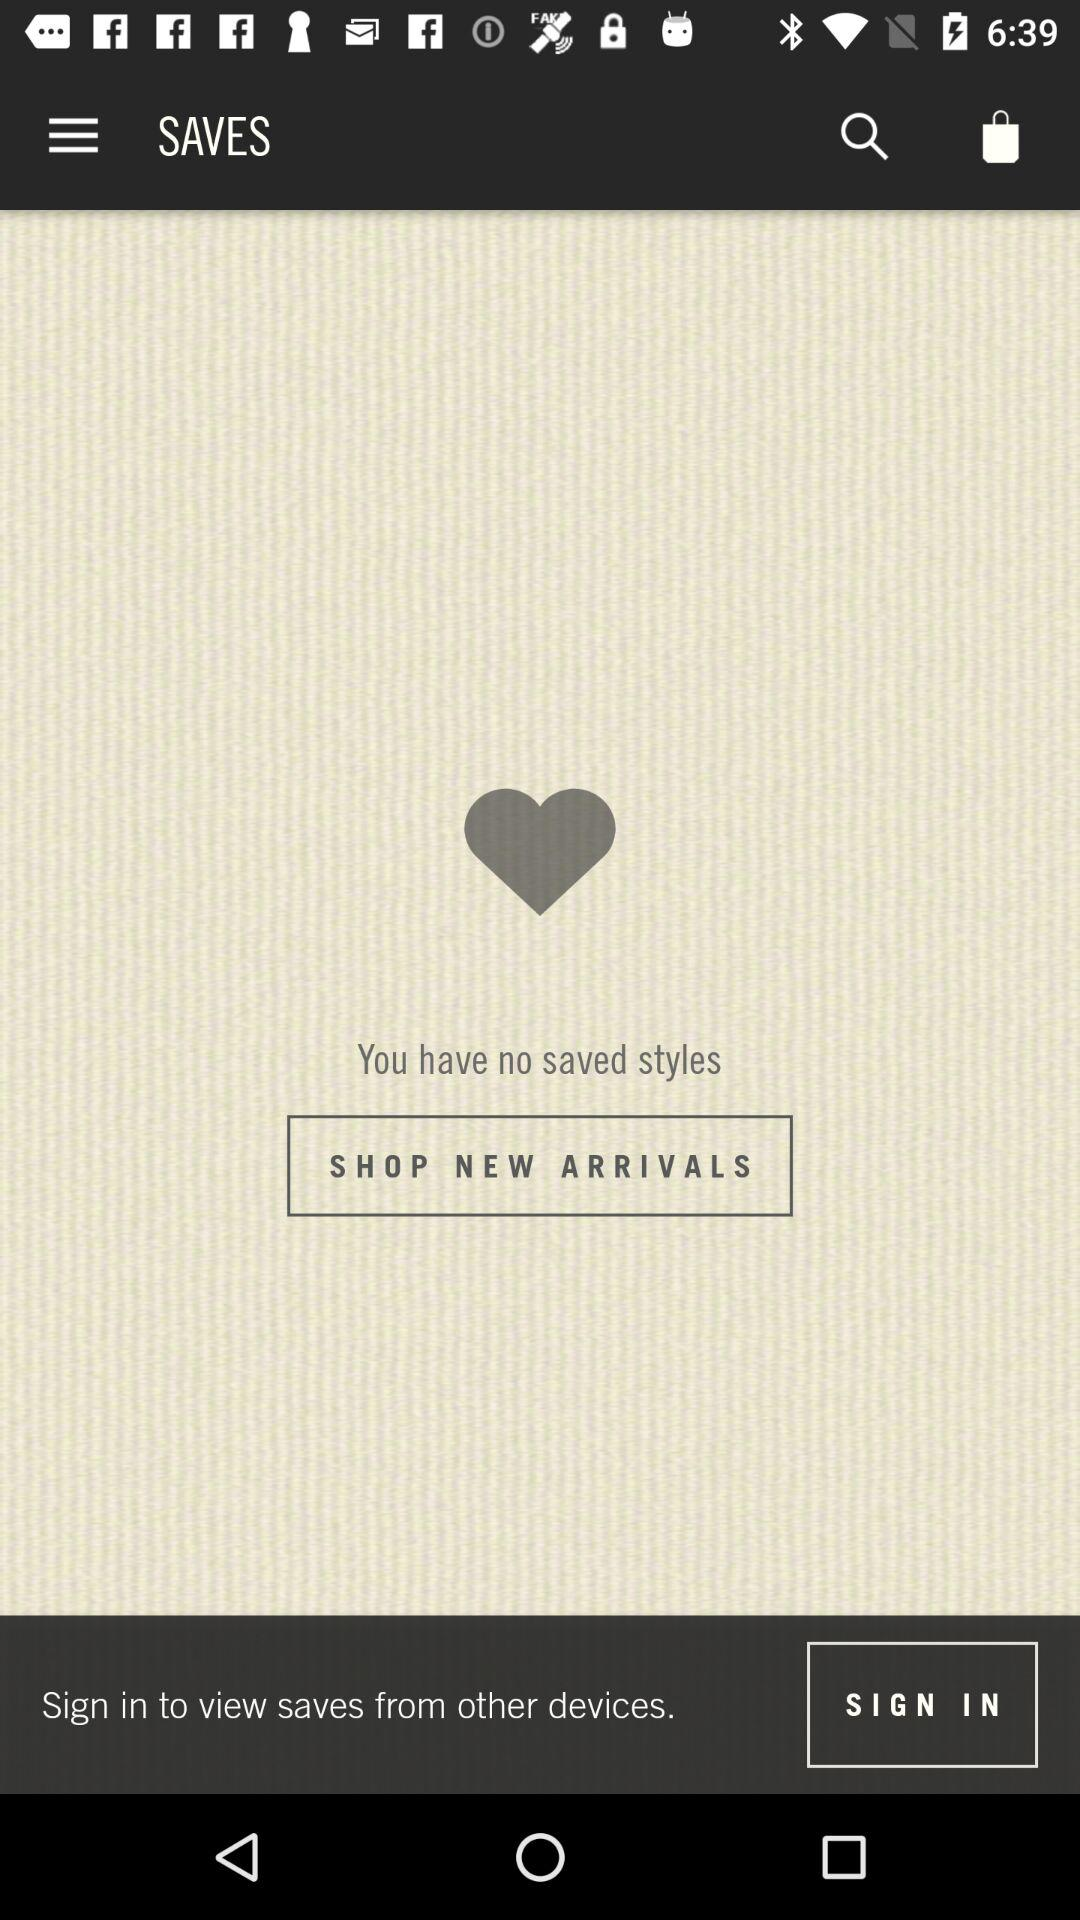What to do to view the saves? You can sign in to view the saves. 